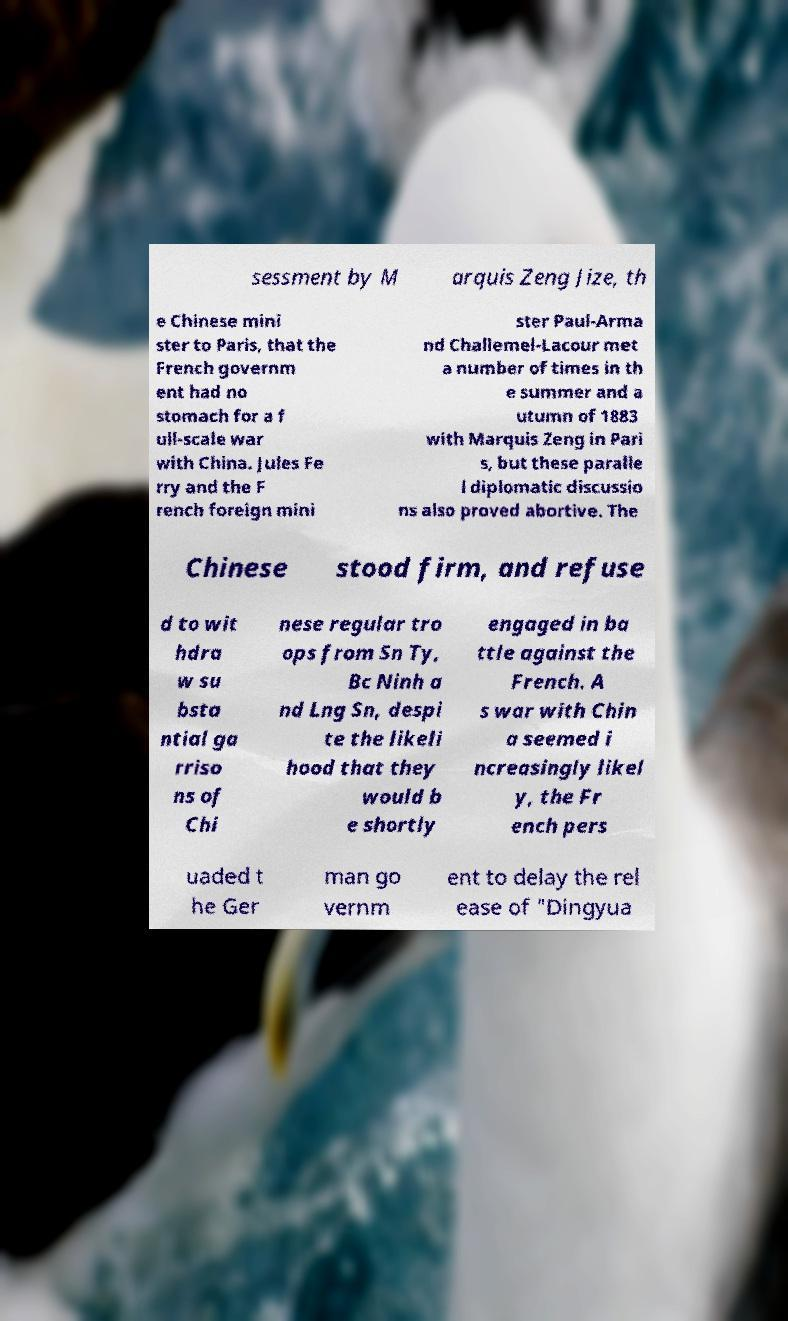Could you extract and type out the text from this image? sessment by M arquis Zeng Jize, th e Chinese mini ster to Paris, that the French governm ent had no stomach for a f ull-scale war with China. Jules Fe rry and the F rench foreign mini ster Paul-Arma nd Challemel-Lacour met a number of times in th e summer and a utumn of 1883 with Marquis Zeng in Pari s, but these paralle l diplomatic discussio ns also proved abortive. The Chinese stood firm, and refuse d to wit hdra w su bsta ntial ga rriso ns of Chi nese regular tro ops from Sn Ty, Bc Ninh a nd Lng Sn, despi te the likeli hood that they would b e shortly engaged in ba ttle against the French. A s war with Chin a seemed i ncreasingly likel y, the Fr ench pers uaded t he Ger man go vernm ent to delay the rel ease of "Dingyua 